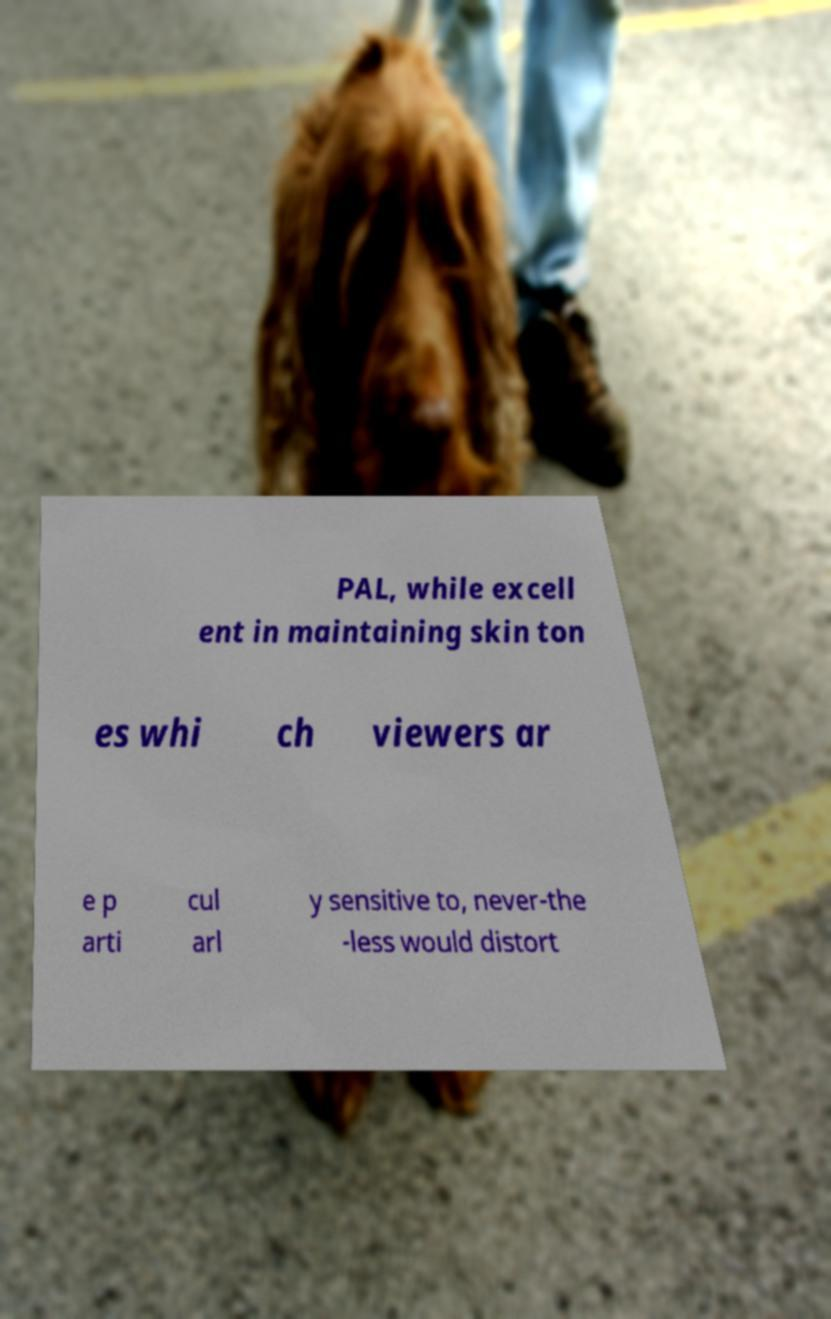What messages or text are displayed in this image? I need them in a readable, typed format. PAL, while excell ent in maintaining skin ton es whi ch viewers ar e p arti cul arl y sensitive to, never-the -less would distort 